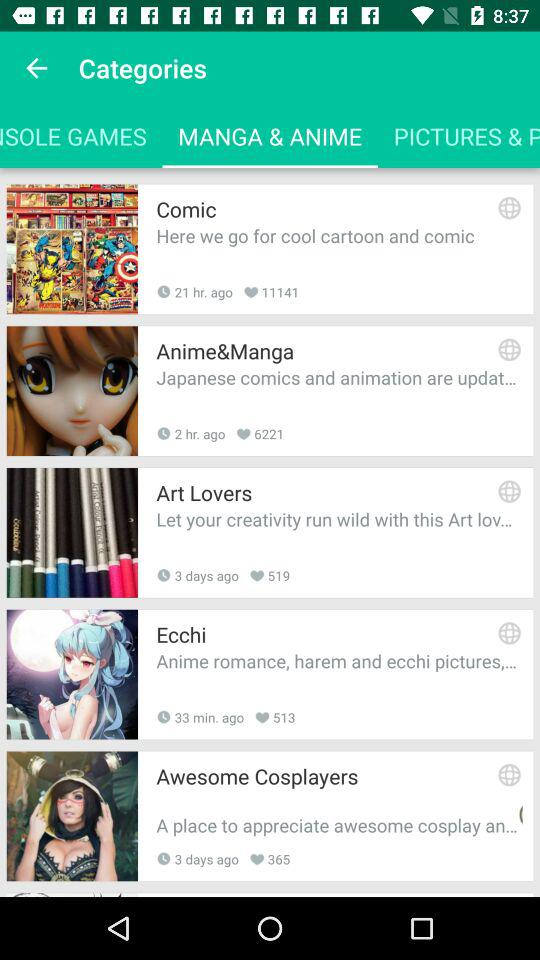When was the post "Art Lovers" posted? The post "Art Lovers" was posted 3 days ago. 